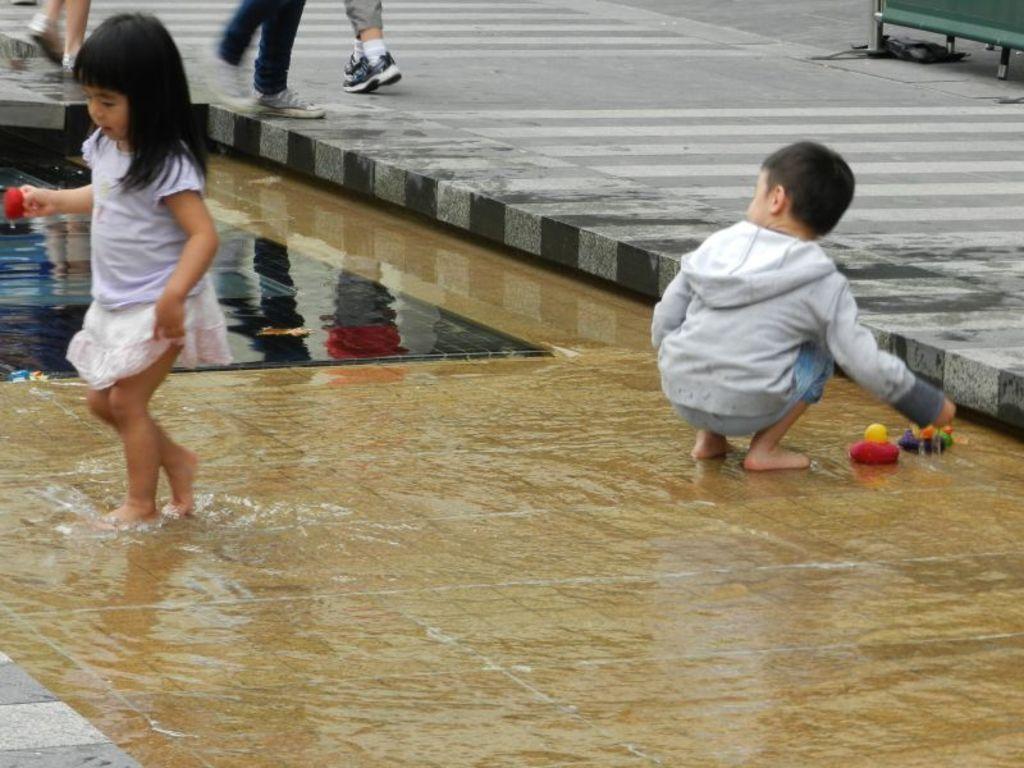How would you summarize this image in a sentence or two? In this image in front there are two children in the water and they are holding the toys. In front of them there are three people walking on the road. On the right side of the image there is some object. 